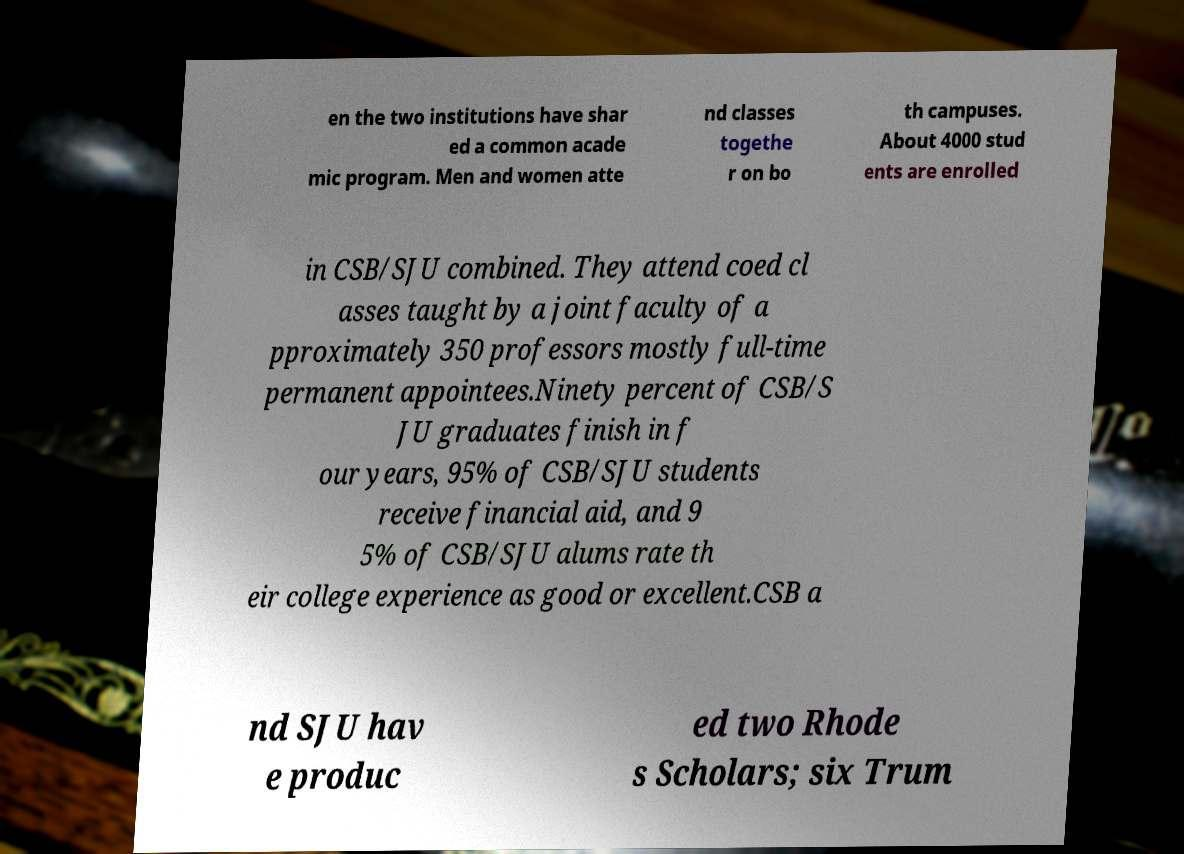There's text embedded in this image that I need extracted. Can you transcribe it verbatim? en the two institutions have shar ed a common acade mic program. Men and women atte nd classes togethe r on bo th campuses. About 4000 stud ents are enrolled in CSB/SJU combined. They attend coed cl asses taught by a joint faculty of a pproximately 350 professors mostly full-time permanent appointees.Ninety percent of CSB/S JU graduates finish in f our years, 95% of CSB/SJU students receive financial aid, and 9 5% of CSB/SJU alums rate th eir college experience as good or excellent.CSB a nd SJU hav e produc ed two Rhode s Scholars; six Trum 